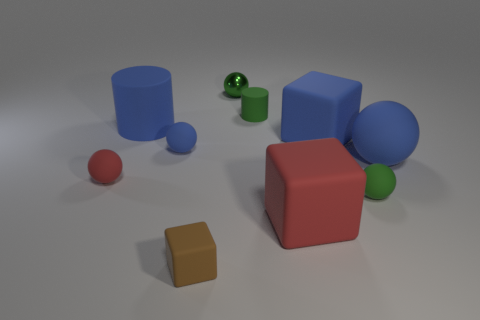Subtract all cyan blocks. How many blue spheres are left? 2 Subtract 1 blocks. How many blocks are left? 2 Subtract all big rubber blocks. How many blocks are left? 1 Subtract all blue balls. How many balls are left? 3 Subtract all cubes. How many objects are left? 7 Subtract all yellow blocks. Subtract all yellow cylinders. How many blocks are left? 3 Add 10 gray spheres. How many gray spheres exist? 10 Subtract 0 cyan balls. How many objects are left? 10 Subtract all small brown rubber cylinders. Subtract all small green metallic balls. How many objects are left? 9 Add 1 brown rubber things. How many brown rubber things are left? 2 